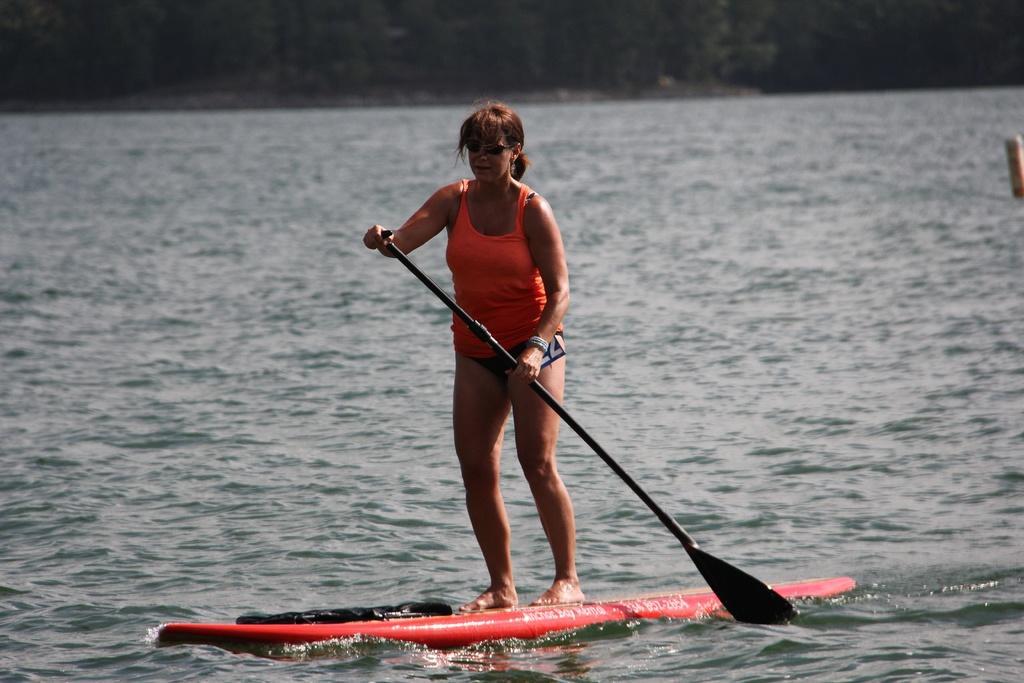Can you describe this image briefly? In this image there is a woman standing on a surfboard. She is rowing with the help of a paddle. There is water around her. 